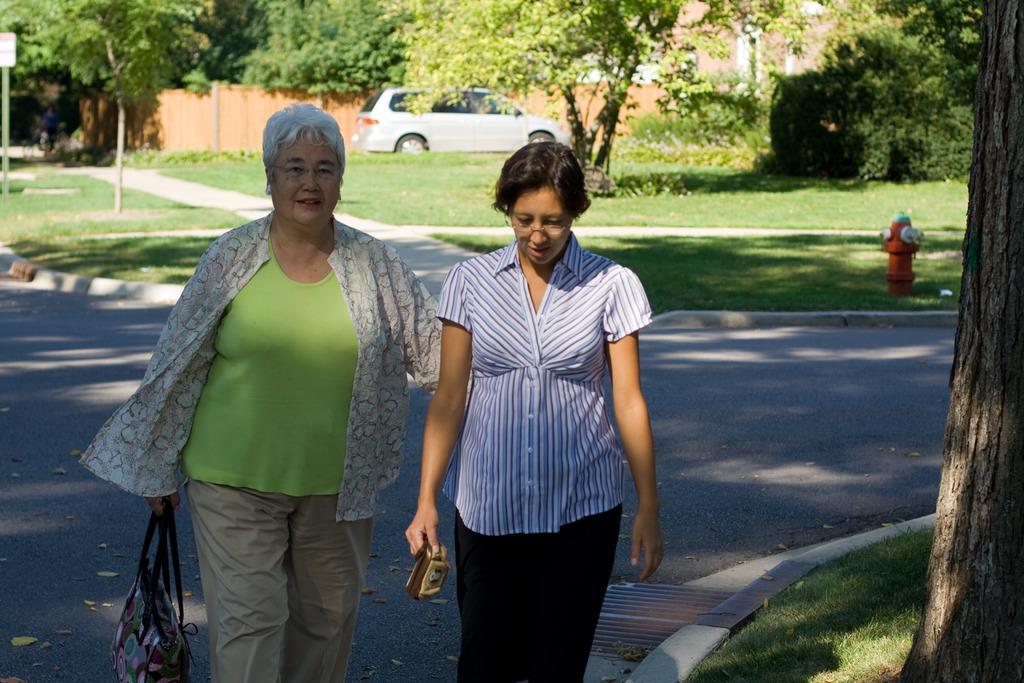Can you describe this image briefly? In this image I can see two women are walking on the road and I can see both of them are holding bags. On the right side of the image I can see a tree trunk and grass. In the background I can see an open grass ground, number of trees, a car, a building and the wall. On the right side of the image I can see a fire hydrant on the ground and on the left side I can see a pole and a white colour board. 